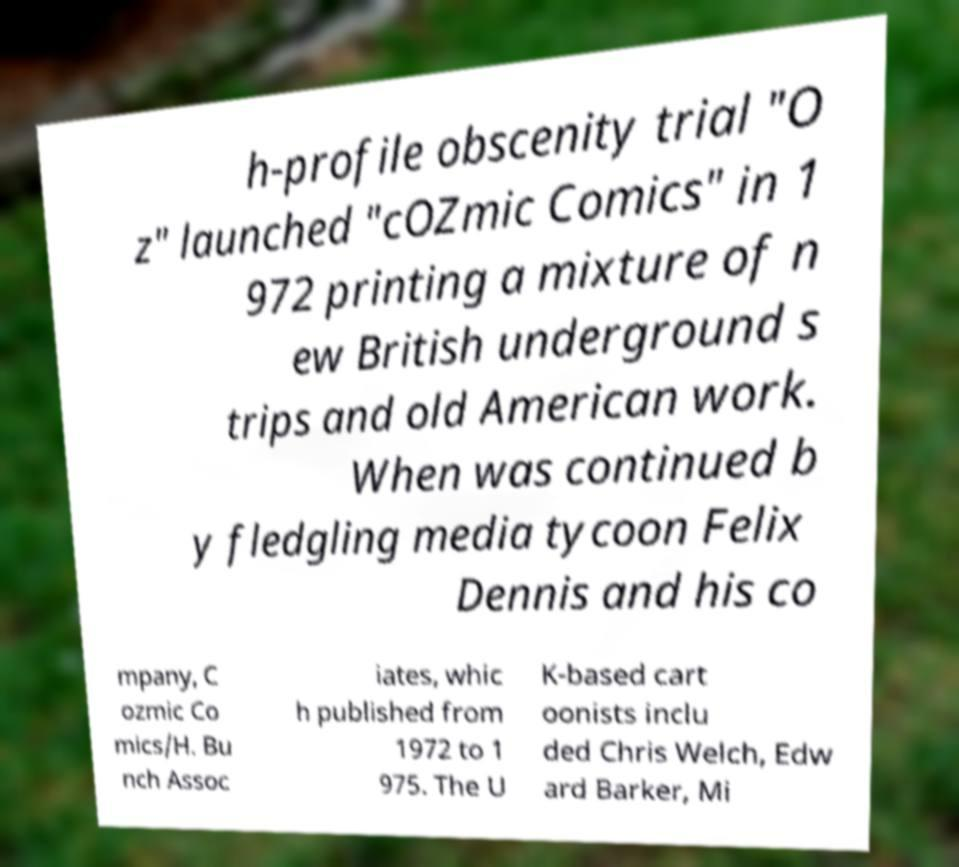Please read and relay the text visible in this image. What does it say? h-profile obscenity trial "O z" launched "cOZmic Comics" in 1 972 printing a mixture of n ew British underground s trips and old American work. When was continued b y fledgling media tycoon Felix Dennis and his co mpany, C ozmic Co mics/H. Bu nch Assoc iates, whic h published from 1972 to 1 975. The U K-based cart oonists inclu ded Chris Welch, Edw ard Barker, Mi 